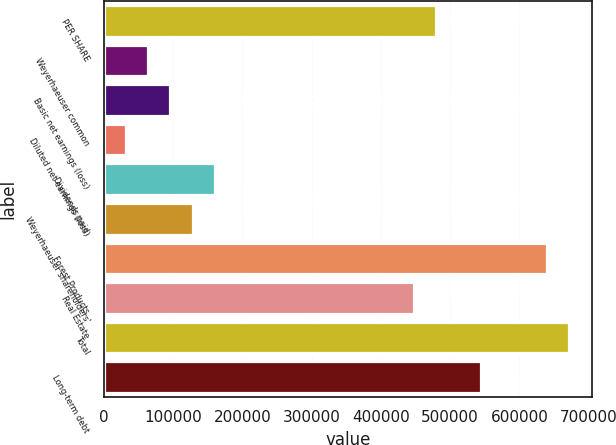Convert chart. <chart><loc_0><loc_0><loc_500><loc_500><bar_chart><fcel>PER SHARE<fcel>Weyerhaeuser common<fcel>Basic net earnings (loss)<fcel>Diluted net earnings (loss)<fcel>Dividends paid<fcel>Weyerhaeuser shareholders'<fcel>Forest Products<fcel>Real Estate<fcel>Total<fcel>Long-term debt<nl><fcel>479963<fcel>63996.8<fcel>95994.2<fcel>31999.4<fcel>159989<fcel>127992<fcel>639950<fcel>447966<fcel>671947<fcel>543958<nl></chart> 